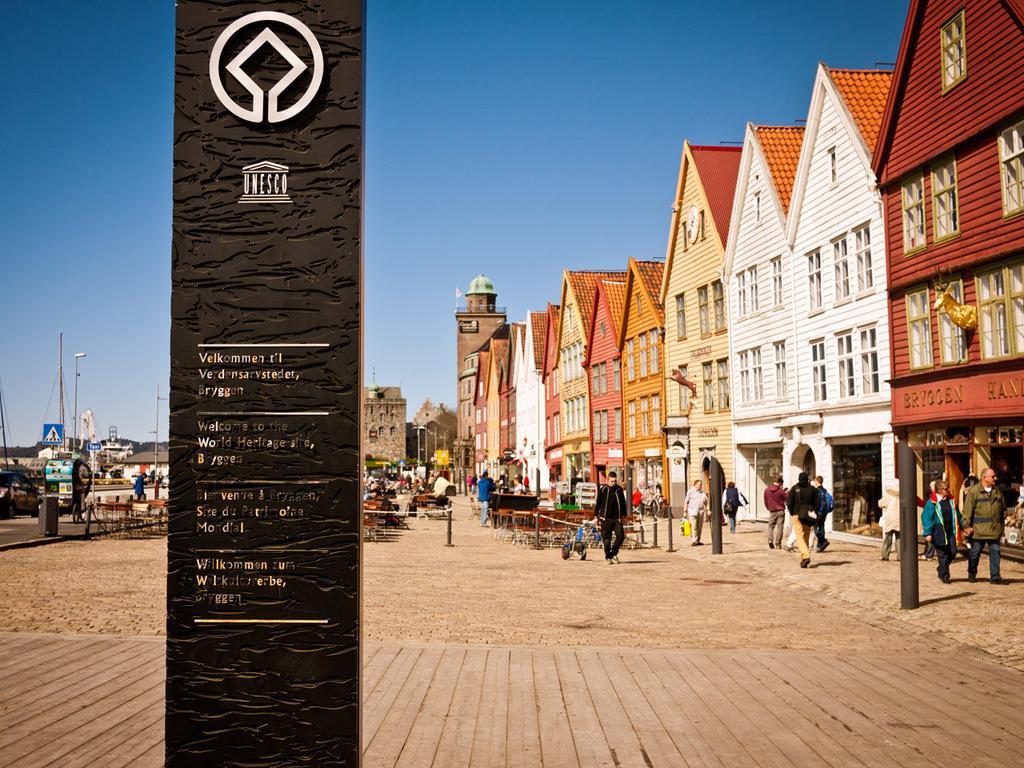How would you summarize this image in a sentence or two? In this picture I can see logos and words on the pillar, there are group of people standing, there are boards, poles, lights, sculptures, there are buildings, trees, and in the background there is sky. 